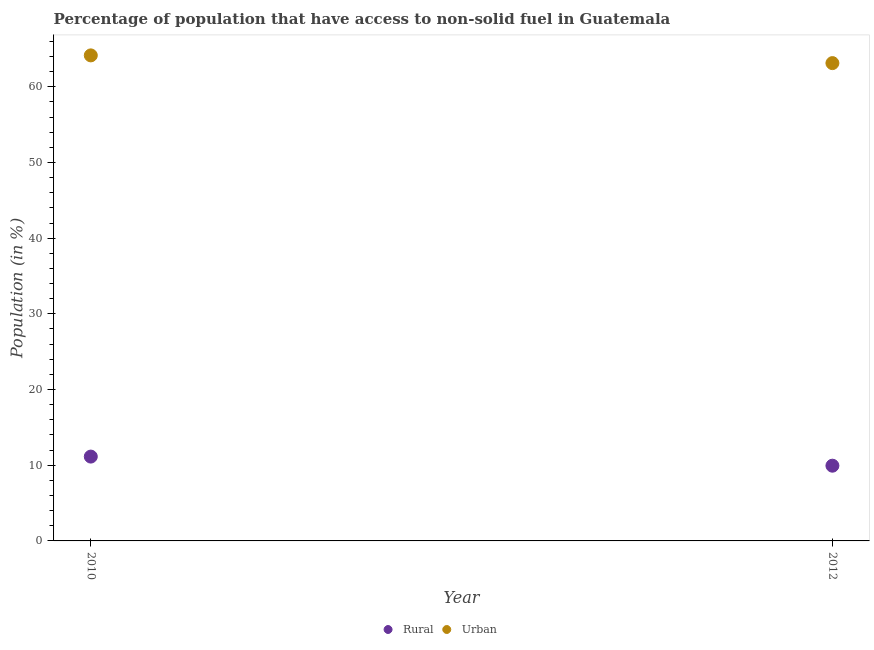How many different coloured dotlines are there?
Give a very brief answer. 2. Is the number of dotlines equal to the number of legend labels?
Keep it short and to the point. Yes. What is the urban population in 2010?
Offer a very short reply. 64.15. Across all years, what is the maximum rural population?
Your answer should be very brief. 11.14. Across all years, what is the minimum urban population?
Keep it short and to the point. 63.13. In which year was the rural population minimum?
Your answer should be very brief. 2012. What is the total rural population in the graph?
Offer a terse response. 21.08. What is the difference between the rural population in 2010 and that in 2012?
Give a very brief answer. 1.2. What is the difference between the rural population in 2010 and the urban population in 2012?
Keep it short and to the point. -51.99. What is the average rural population per year?
Provide a short and direct response. 10.54. In the year 2010, what is the difference between the urban population and rural population?
Provide a succinct answer. 53.01. What is the ratio of the urban population in 2010 to that in 2012?
Give a very brief answer. 1.02. In how many years, is the rural population greater than the average rural population taken over all years?
Keep it short and to the point. 1. Does the rural population monotonically increase over the years?
Offer a terse response. No. Is the urban population strictly greater than the rural population over the years?
Provide a succinct answer. Yes. Is the urban population strictly less than the rural population over the years?
Keep it short and to the point. No. How many dotlines are there?
Give a very brief answer. 2. What is the difference between two consecutive major ticks on the Y-axis?
Offer a terse response. 10. Are the values on the major ticks of Y-axis written in scientific E-notation?
Provide a short and direct response. No. Does the graph contain grids?
Keep it short and to the point. No. Where does the legend appear in the graph?
Offer a very short reply. Bottom center. How many legend labels are there?
Your answer should be very brief. 2. How are the legend labels stacked?
Provide a short and direct response. Horizontal. What is the title of the graph?
Offer a very short reply. Percentage of population that have access to non-solid fuel in Guatemala. What is the label or title of the Y-axis?
Make the answer very short. Population (in %). What is the Population (in %) of Rural in 2010?
Make the answer very short. 11.14. What is the Population (in %) of Urban in 2010?
Provide a short and direct response. 64.15. What is the Population (in %) in Rural in 2012?
Ensure brevity in your answer.  9.94. What is the Population (in %) of Urban in 2012?
Offer a very short reply. 63.13. Across all years, what is the maximum Population (in %) in Rural?
Ensure brevity in your answer.  11.14. Across all years, what is the maximum Population (in %) of Urban?
Offer a terse response. 64.15. Across all years, what is the minimum Population (in %) in Rural?
Keep it short and to the point. 9.94. Across all years, what is the minimum Population (in %) of Urban?
Provide a succinct answer. 63.13. What is the total Population (in %) in Rural in the graph?
Provide a short and direct response. 21.08. What is the total Population (in %) of Urban in the graph?
Make the answer very short. 127.28. What is the difference between the Population (in %) of Rural in 2010 and that in 2012?
Ensure brevity in your answer.  1.2. What is the difference between the Population (in %) of Urban in 2010 and that in 2012?
Ensure brevity in your answer.  1.02. What is the difference between the Population (in %) of Rural in 2010 and the Population (in %) of Urban in 2012?
Your answer should be compact. -51.99. What is the average Population (in %) of Rural per year?
Ensure brevity in your answer.  10.54. What is the average Population (in %) in Urban per year?
Offer a terse response. 63.64. In the year 2010, what is the difference between the Population (in %) of Rural and Population (in %) of Urban?
Make the answer very short. -53.01. In the year 2012, what is the difference between the Population (in %) in Rural and Population (in %) in Urban?
Give a very brief answer. -53.19. What is the ratio of the Population (in %) in Rural in 2010 to that in 2012?
Offer a very short reply. 1.12. What is the ratio of the Population (in %) of Urban in 2010 to that in 2012?
Give a very brief answer. 1.02. What is the difference between the highest and the second highest Population (in %) in Rural?
Ensure brevity in your answer.  1.2. What is the difference between the highest and the second highest Population (in %) in Urban?
Provide a succinct answer. 1.02. What is the difference between the highest and the lowest Population (in %) in Rural?
Make the answer very short. 1.2. What is the difference between the highest and the lowest Population (in %) of Urban?
Offer a terse response. 1.02. 